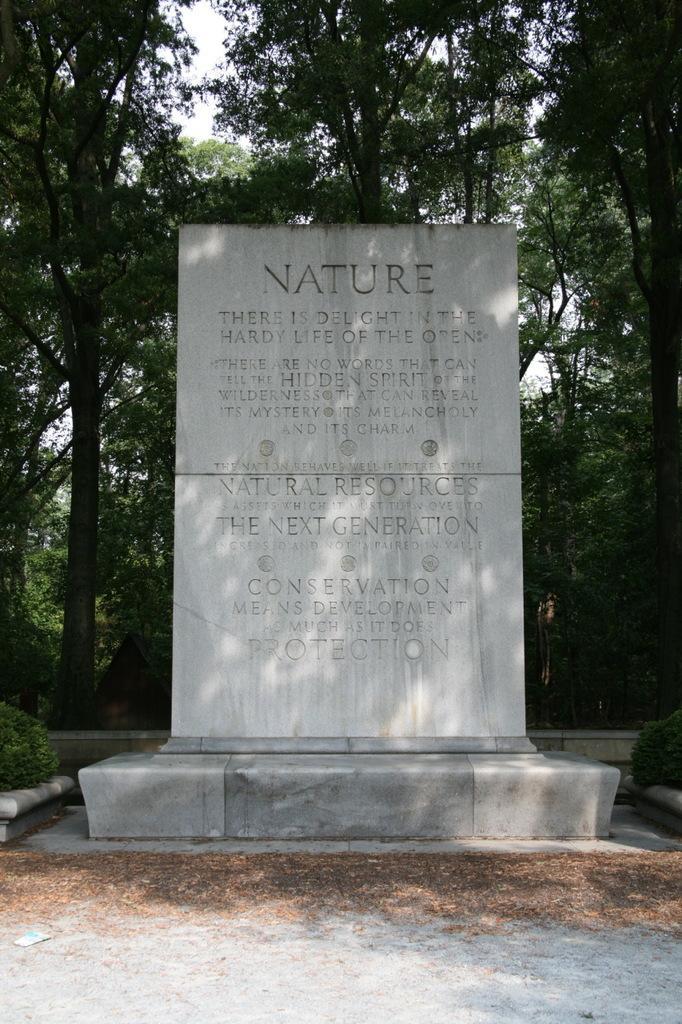In one or two sentences, can you explain what this image depicts? In this image there is a big rock with note in it, behind that there are so many trees. 